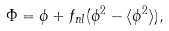<formula> <loc_0><loc_0><loc_500><loc_500>\Phi = \phi + f _ { n l } ( \phi ^ { 2 } - \langle \phi ^ { 2 } \rangle ) ,</formula> 